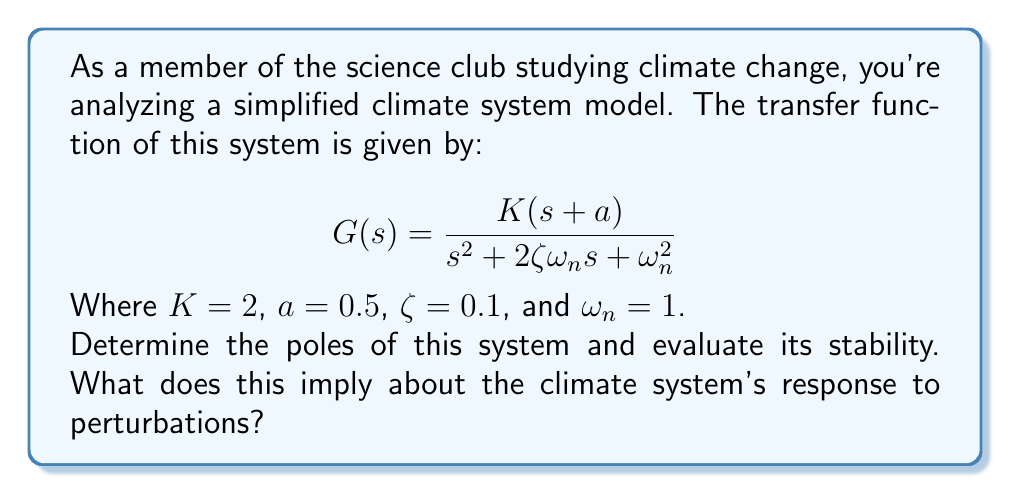Teach me how to tackle this problem. To evaluate the stability of the system, we need to find its poles and analyze their location in the complex plane.

Step 1: Identify the characteristic equation
The characteristic equation is the denominator of the transfer function set to zero:
$$s^2 + 2\zeta\omega_n s + \omega_n^2 = 0$$

Step 2: Substitute the given values
$$s^2 + 2(0.1)(1)s + 1^2 = 0$$
$$s^2 + 0.2s + 1 = 0$$

Step 3: Solve for s using the quadratic formula
$$s = \frac{-b \pm \sqrt{b^2 - 4ac}}{2a}$$
$$s = \frac{-0.2 \pm \sqrt{0.2^2 - 4(1)(1)}}{2(1)}$$
$$s = -0.1 \pm \sqrt{0.04 - 4}$$
$$s = -0.1 \pm \sqrt{-3.96}$$
$$s = -0.1 \pm 1.99i$$

Step 4: Express the poles
The poles are:
$$s_1 = -0.1 + 1.99i$$
$$s_2 = -0.1 - 1.99i$$

Step 5: Analyze stability
For a system to be stable, all poles must have negative real parts. In this case, both poles have a real part of -0.1, which is negative. Therefore, the system is stable.

Step 6: Interpret the results
The negative real parts indicate that the system will eventually return to equilibrium after a perturbation. However, the small magnitude of the real part (-0.1) suggests a slow decay of oscillations. The large imaginary parts (±1.99i) indicate that the system will oscillate significantly before settling.

In the context of climate systems, this implies that the modeled climate system is stable but highly sensitive to perturbations. It will eventually return to equilibrium after disturbances, but with prolonged oscillations. This could represent a climate that experiences long-term fluctuations in response to external forcings before stabilizing.
Answer: Stable system with poles at $-0.1 \pm 1.99i$; slow decay with significant oscillations. 